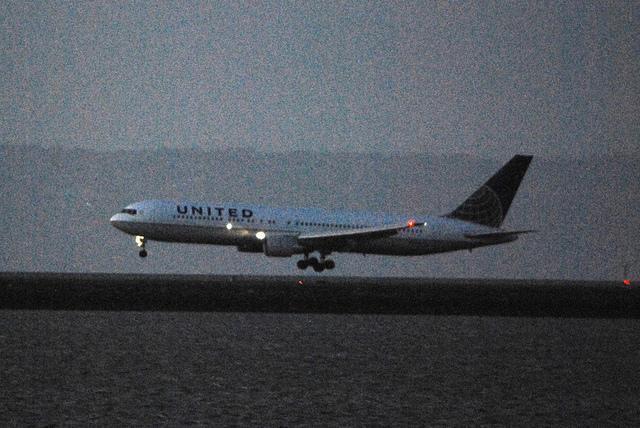How many people are on the motorcycle?
Give a very brief answer. 0. 